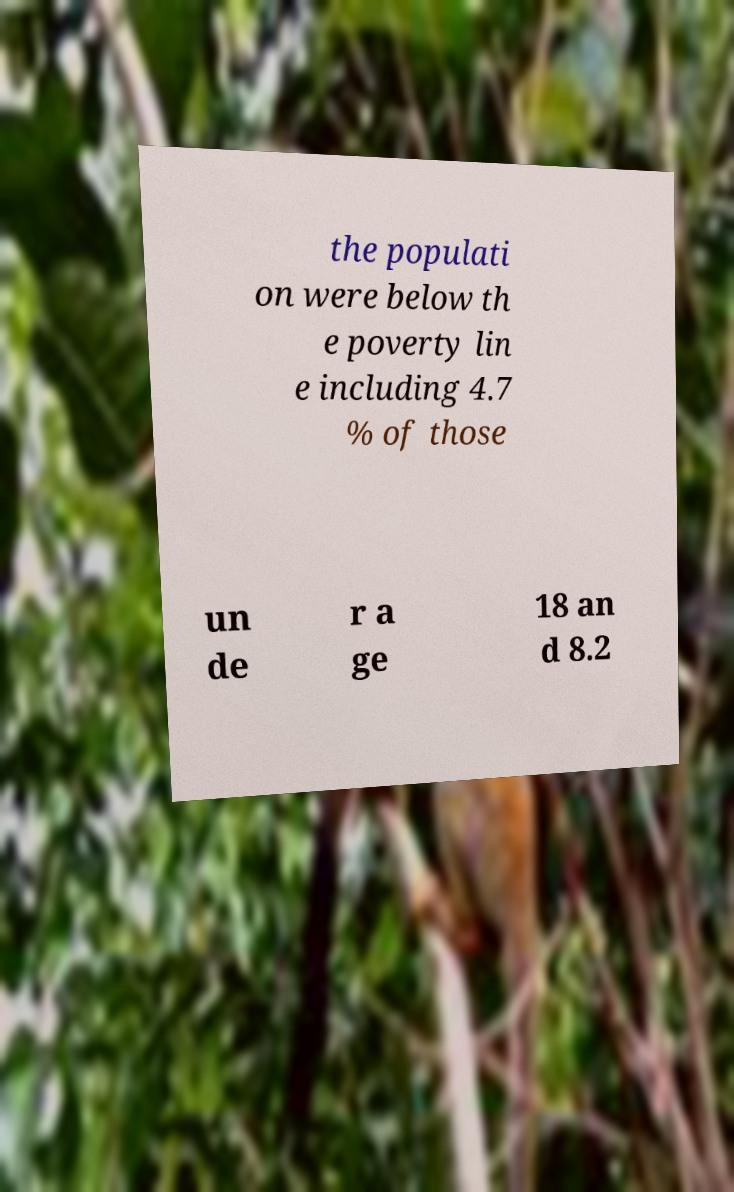Please identify and transcribe the text found in this image. the populati on were below th e poverty lin e including 4.7 % of those un de r a ge 18 an d 8.2 